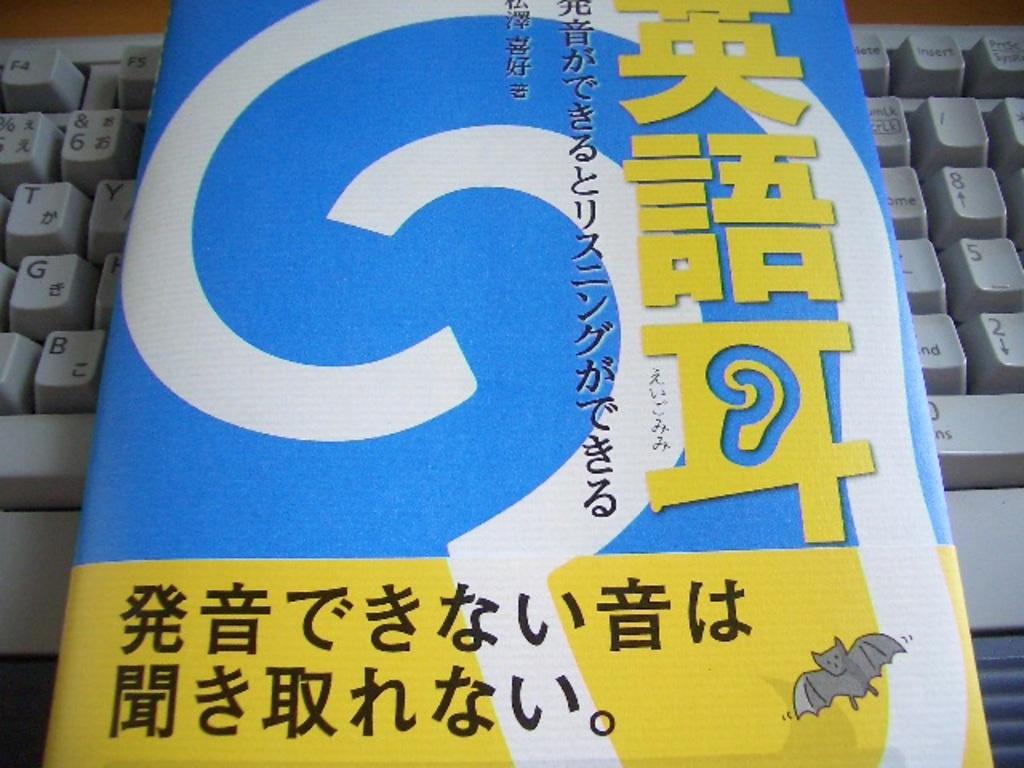What animal is in the bottom right corner?
Provide a succinct answer. Answering does not require reading text in the image. What number is between the 2 and 8 on the keyboard's number pad in the picture?
Provide a short and direct response. 5. 